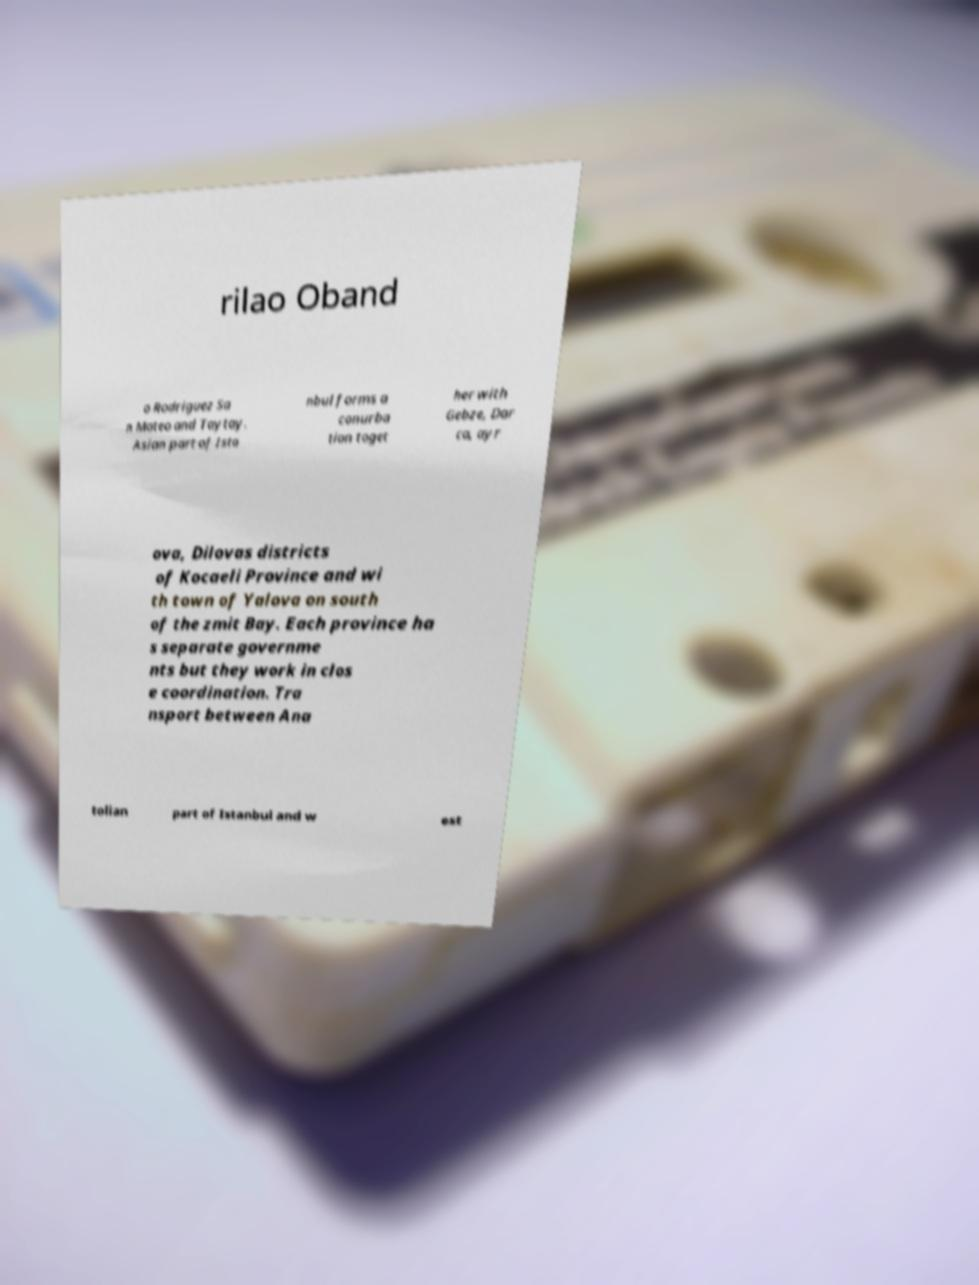Could you assist in decoding the text presented in this image and type it out clearly? rilao Oband o Rodriguez Sa n Mateo and Taytay. Asian part of Ista nbul forms a conurba tion toget her with Gebze, Dar ca, ayr ova, Dilovas districts of Kocaeli Province and wi th town of Yalova on south of the zmit Bay. Each province ha s separate governme nts but they work in clos e coordination. Tra nsport between Ana tolian part of Istanbul and w est 